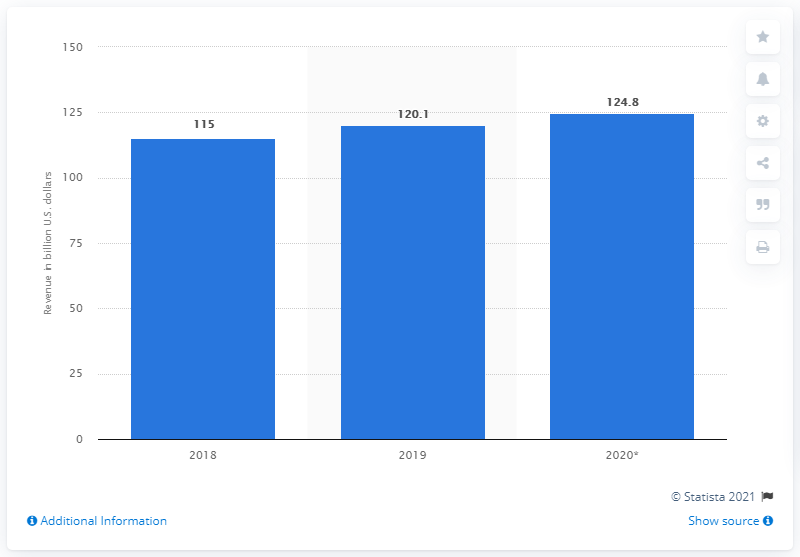Mention a couple of crucial points in this snapshot. By 2020, it is expected to generate around 124.8 billion dollars from digital games and interactive media. The estimated revenue of digital games and interactive media in the United States in 2018 and 2019 was approximately $115 billion. 